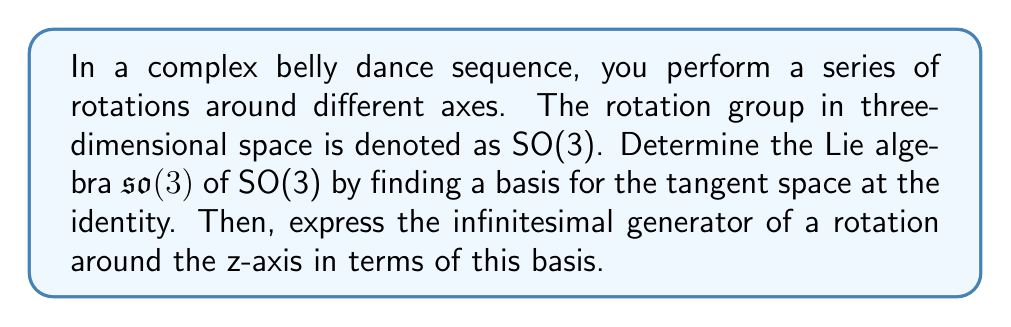Show me your answer to this math problem. To solve this problem, we'll follow these steps:

1) The Lie algebra $\mathfrak{so}(3)$ consists of 3×3 skew-symmetric matrices. A general skew-symmetric matrix has the form:

   $$A = \begin{pmatrix}
   0 & -a & b \\
   a & 0 & -c \\
   -b & c & 0
   \end{pmatrix}$$

2) We can choose a basis for $\mathfrak{so}(3)$ by selecting three linearly independent skew-symmetric matrices:

   $$E_1 = \begin{pmatrix}
   0 & 0 & 0 \\
   0 & 0 & -1 \\
   0 & 1 & 0
   \end{pmatrix}, 
   E_2 = \begin{pmatrix}
   0 & 0 & 1 \\
   0 & 0 & 0 \\
   -1 & 0 & 0
   \end{pmatrix}, 
   E_3 = \begin{pmatrix}
   0 & -1 & 0 \\
   1 & 0 & 0 \\
   0 & 0 & 0
   \end{pmatrix}$$

3) These matrices correspond to infinitesimal rotations around the x, y, and z axes respectively.

4) The infinitesimal generator of a rotation around the z-axis is precisely $E_3$.

5) We can verify that these matrices satisfy the commutation relations of $\mathfrak{so}(3)$:

   $$[E_1, E_2] = E_3, [E_2, E_3] = E_1, [E_3, E_1] = E_2$$

   where $[A,B] = AB - BA$ is the Lie bracket.

6) Any element of $\mathfrak{so}(3)$ can be expressed as a linear combination of these basis elements:

   $$X = aE_1 + bE_2 + cE_3$$

   where $a$, $b$, and $c$ are real numbers.

Therefore, $\{E_1, E_2, E_3\}$ forms a basis for $\mathfrak{so}(3)$, and the infinitesimal generator of a rotation around the z-axis is $E_3$.
Answer: The Lie algebra $\mathfrak{so}(3)$ of SO(3) has the basis $\{E_1, E_2, E_3\}$ where:

$$E_1 = \begin{pmatrix}
0 & 0 & 0 \\
0 & 0 & -1 \\
0 & 1 & 0
\end{pmatrix}, 
E_2 = \begin{pmatrix}
0 & 0 & 1 \\
0 & 0 & 0 \\
-1 & 0 & 0
\end{pmatrix}, 
E_3 = \begin{pmatrix}
0 & -1 & 0 \\
1 & 0 & 0 \\
0 & 0 & 0
\end{pmatrix}$$

The infinitesimal generator of a rotation around the z-axis is $E_3$. 